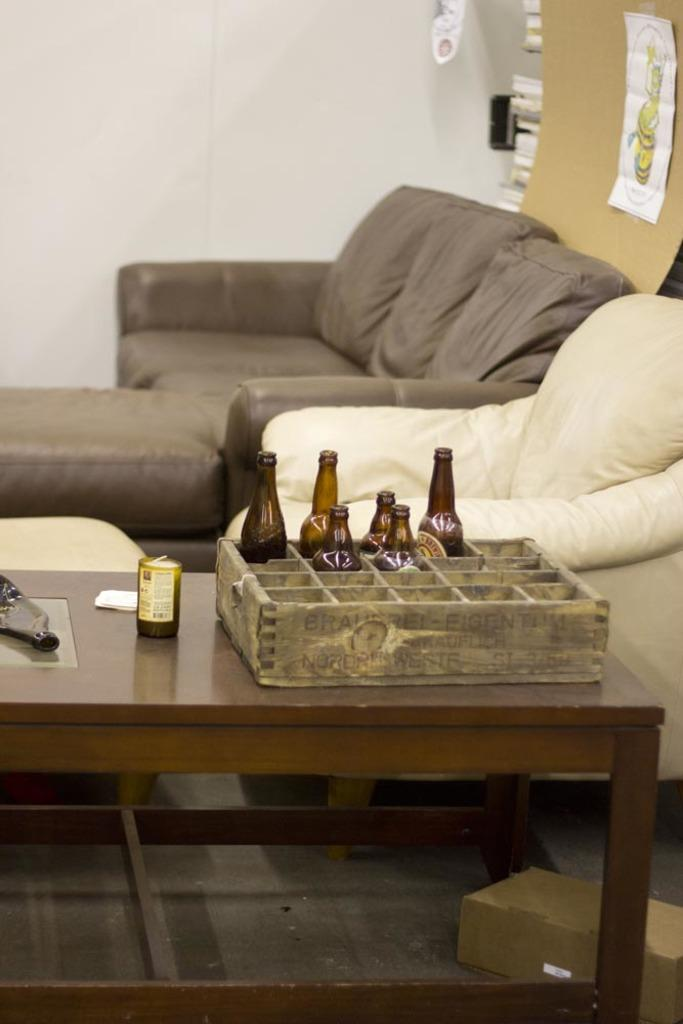What type of furniture is present in the image? There is a couch and a chair in the image. What is on the table in the image? There are bottles on a table in the image. What type of rail can be seen in the image? There is no rail present in the image. Who is the representative sitting on the couch in the image? The image does not depict a specific person or representative; it only shows a couch and a chair. 